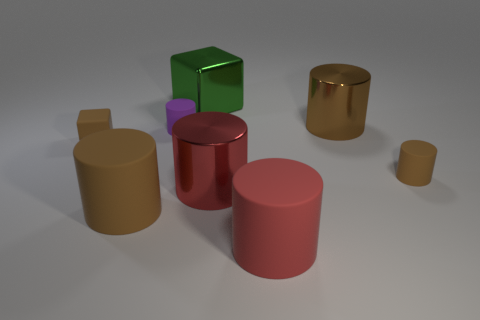Subtract all tiny brown matte cylinders. How many cylinders are left? 5 Subtract all cyan balls. How many brown cylinders are left? 3 Subtract 3 cylinders. How many cylinders are left? 3 Subtract all brown cylinders. How many cylinders are left? 3 Add 2 tiny brown cylinders. How many objects exist? 10 Subtract all purple cylinders. Subtract all green blocks. How many cylinders are left? 5 Subtract all blocks. How many objects are left? 6 Add 1 big red rubber things. How many big red rubber things exist? 2 Subtract 0 blue balls. How many objects are left? 8 Subtract all tiny matte cubes. Subtract all purple matte cylinders. How many objects are left? 6 